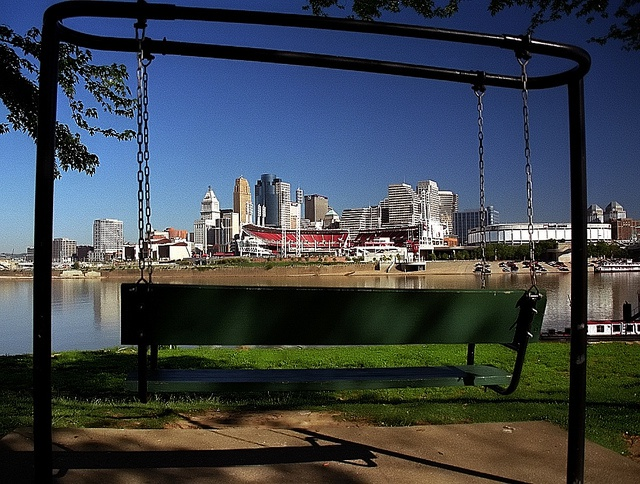Describe the objects in this image and their specific colors. I can see bench in darkblue, black, darkgreen, and gray tones, boat in darkblue, black, white, gray, and maroon tones, boat in darkblue, white, black, gray, and darkgray tones, boat in darkblue, tan, and beige tones, and car in darkblue, black, gray, darkgray, and lightgray tones in this image. 